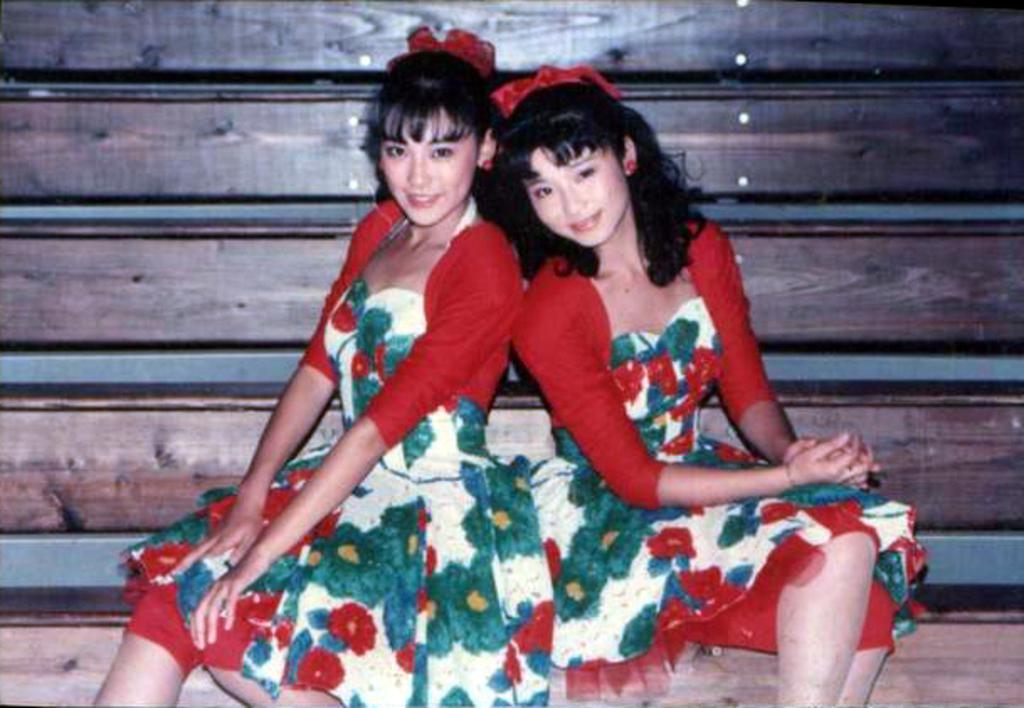Can you describe this image briefly? In this image we can see two persons wearing similar color dress which is of red color and also wearing head ribbon and in the background of the image we can see some wooden surface. 